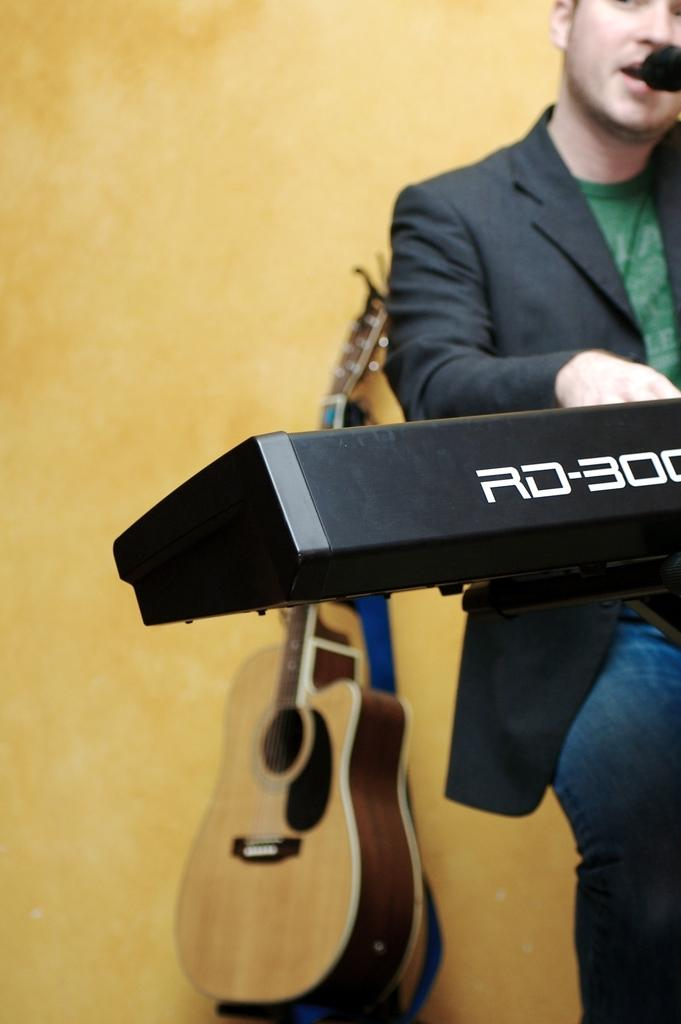What is the man in the image doing? The man is sitting and playing a piano. Is the man also doing something else while playing the piano? Yes, the man is singing a song. What other musical instrument can be seen in the background of the image? There is a guitar in the background of the image. What is the condition of the guitar in the image? The guitar is kept aside. What type of wrench is the man using to tune the guitar in the image? There is no wrench present in the image, and the guitar is kept aside, so it cannot be tuned. 